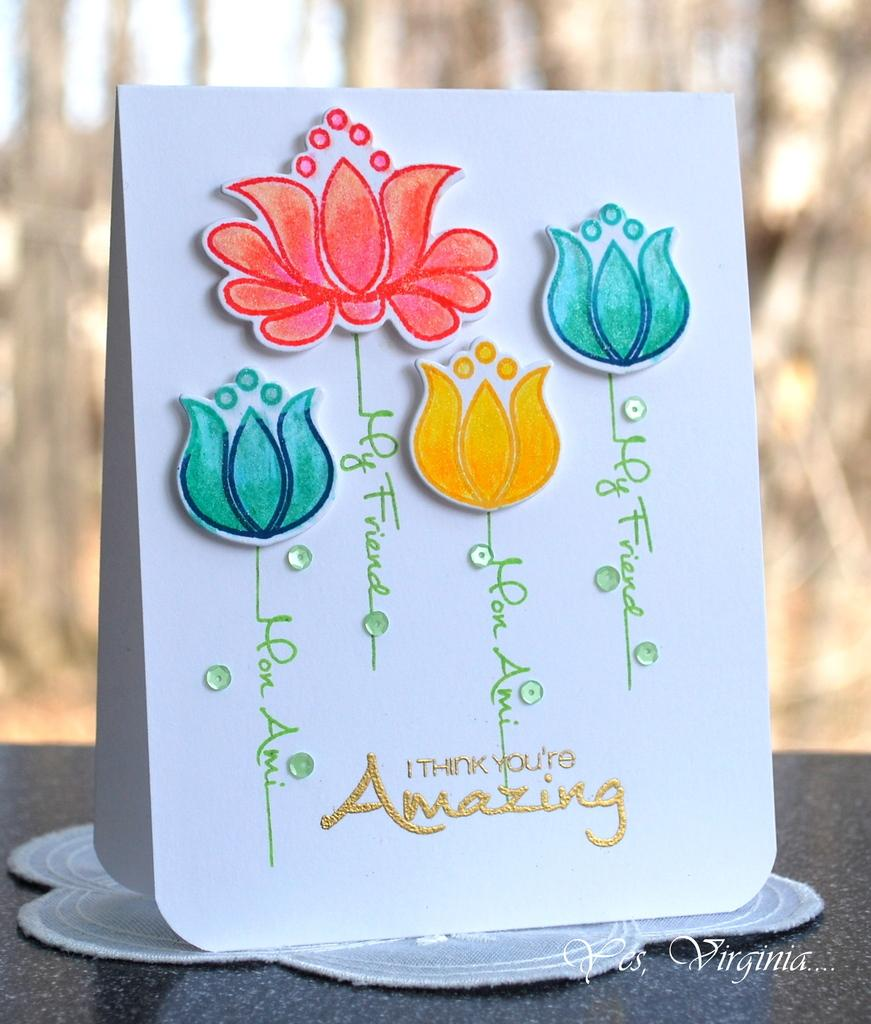What object is on the table in the image? There is a gift card on the table in the image. What can be read or seen in the image? There is text visible in the image. When was the image likely taken? The image was taken during the day. What type of produce is being harvested in the image? There is no produce or harvesting activity present in the image; it features a gift card on a table. How does the image capture the attention of the viewer? The image does not capture the attention of the viewer in any specific way, as it only shows a gift card on a table. 